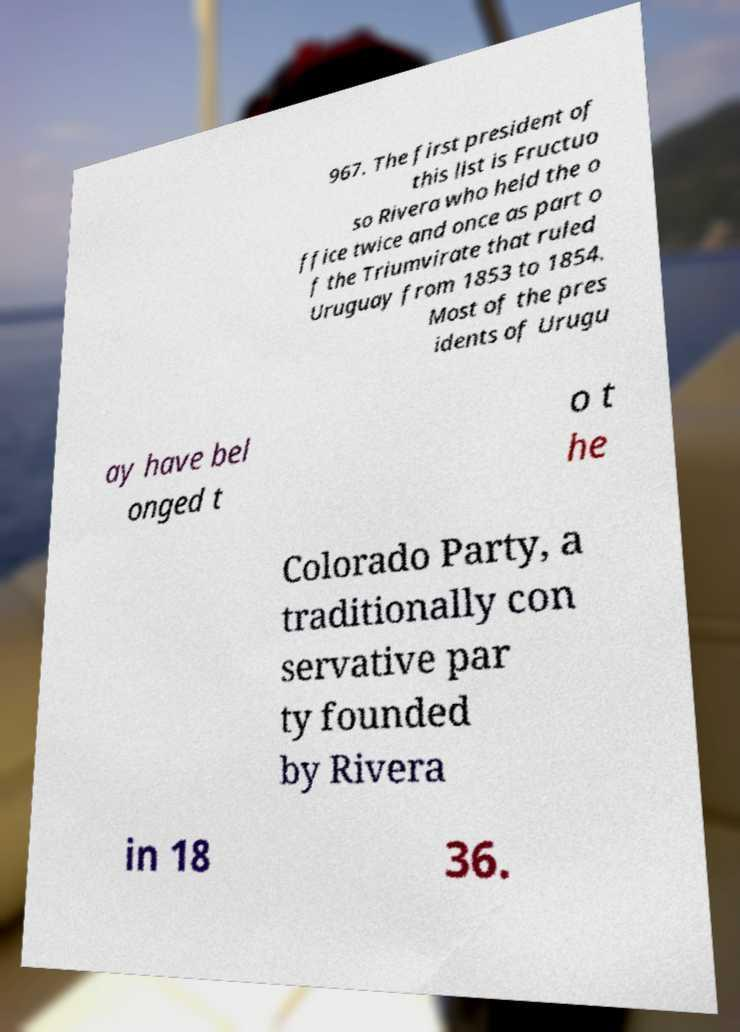For documentation purposes, I need the text within this image transcribed. Could you provide that? 967. The first president of this list is Fructuo so Rivera who held the o ffice twice and once as part o f the Triumvirate that ruled Uruguay from 1853 to 1854. Most of the pres idents of Urugu ay have bel onged t o t he Colorado Party, a traditionally con servative par ty founded by Rivera in 18 36. 